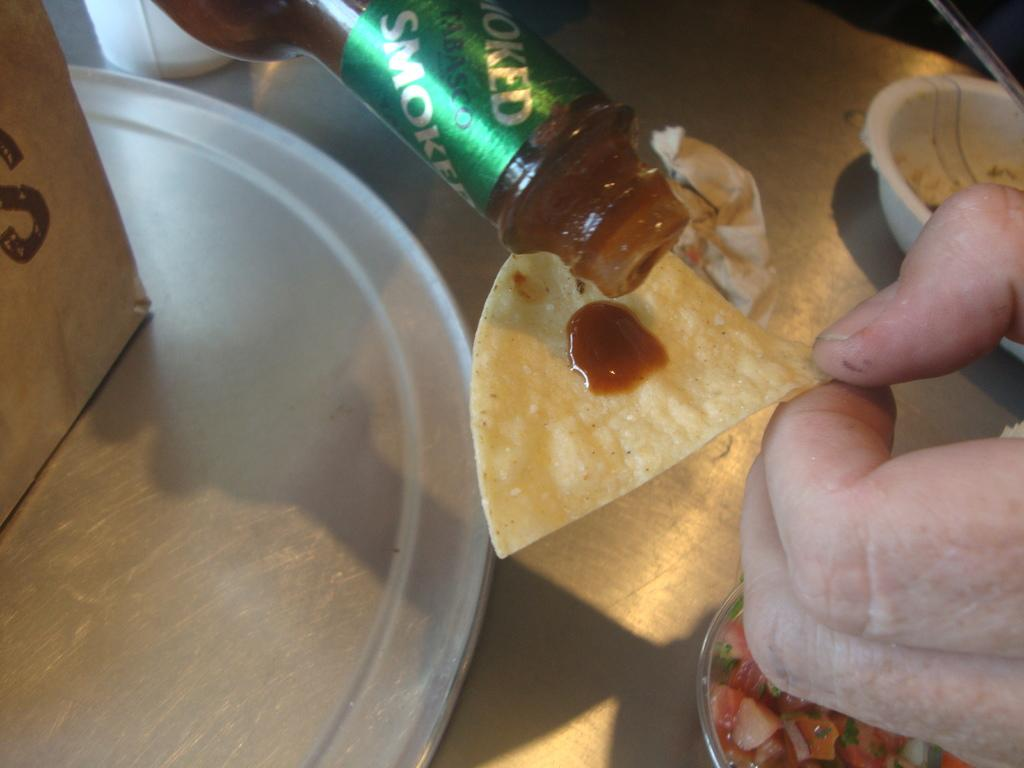Provide a one-sentence caption for the provided image. Someone pouring Smoked Tabasco sauce on to a tortilla chip. 